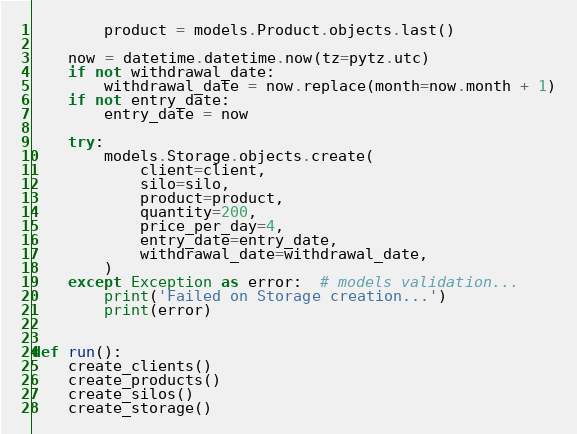<code> <loc_0><loc_0><loc_500><loc_500><_Python_>        product = models.Product.objects.last()

    now = datetime.datetime.now(tz=pytz.utc)
    if not withdrawal_date:
        withdrawal_date = now.replace(month=now.month + 1)
    if not entry_date:
        entry_date = now

    try:
        models.Storage.objects.create(
            client=client,
            silo=silo,
            product=product,
            quantity=200,
            price_per_day=4,
            entry_date=entry_date,
            withdrawal_date=withdrawal_date,
        )
    except Exception as error:  # models validation...
        print('Failed on Storage creation...')
        print(error)


def run():
    create_clients()
    create_products()
    create_silos()
    create_storage()
</code> 